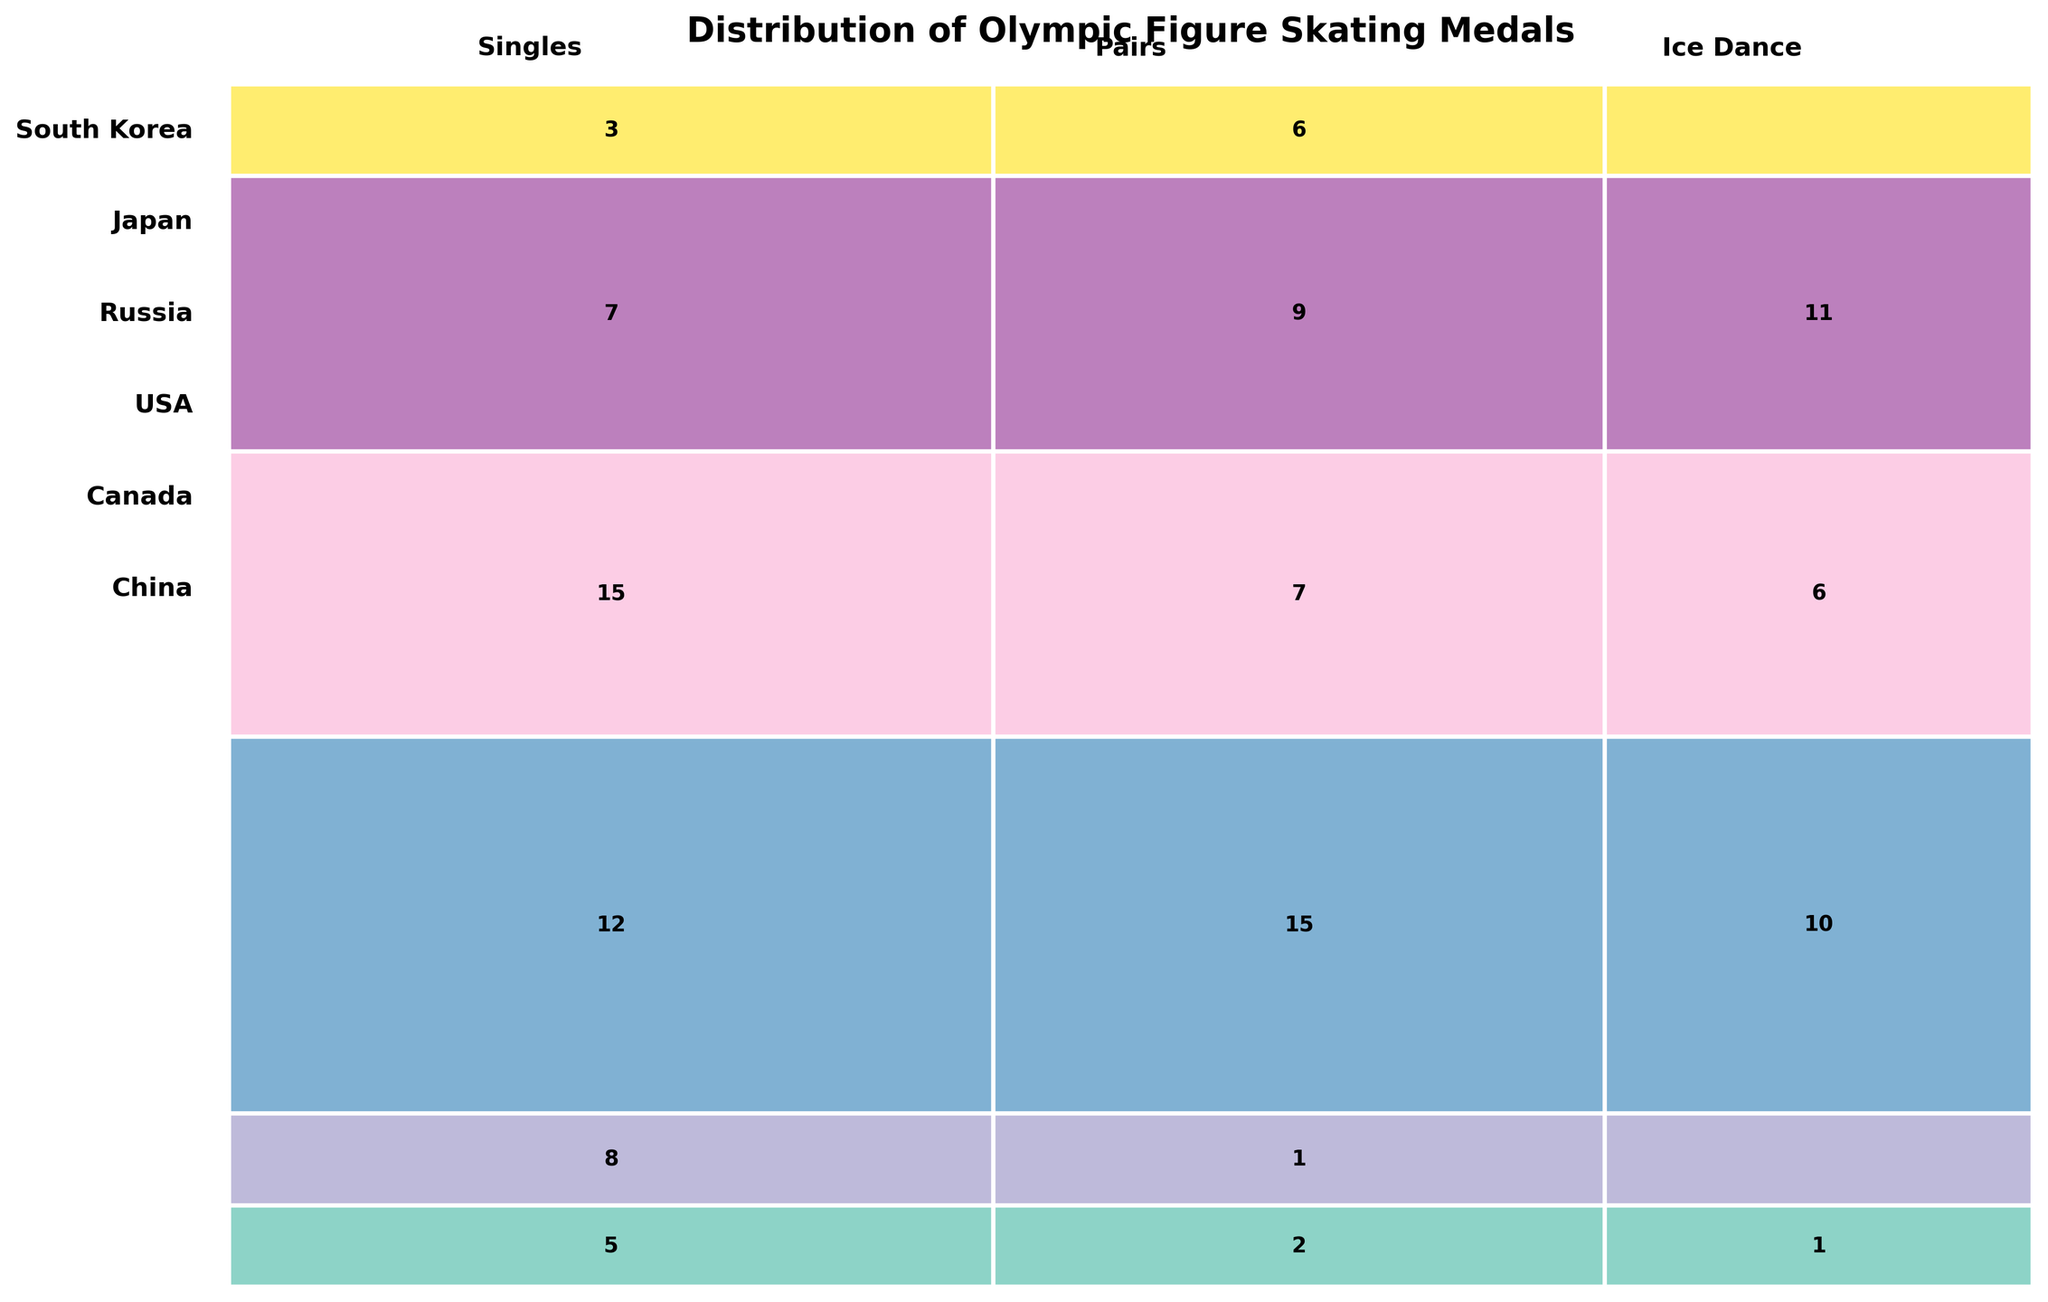Which country has the most medals in Singles figure skating? Look for the country with the largest rectangle in the Singles category and identify its corresponding medal count.
Answer: USA How many more medals does Russia have in Pairs compared to Ice Dance? Find the medal counts for Russia in both Pairs and Ice Dance, then subtract the Ice Dance count from the Pairs count (15 - 10).
Answer: 5 Which discipline has the least medals won by Japan? Identify the smallest rectangle in each discipline for Japan. The smallest is Ice Dance with a count of 0.
Answer: Ice Dance Compare the total medals won by South Korea and Canada. Which country has more? Add the medals from all disciplines for both South Korea and Canada. South Korea has 8 medals (5+2+1) and Canada has 27 (7+9+11).
Answer: Canada How do the number of medals won by China in Singles compare to those won in Pairs? Look at the numbers of the respective rectangles for China in Singles and Pairs. China has 3 in Singles and 6 in Pairs.
Answer: Pairs (6) are greater than Singles (3) Which discipline has the largest share of total medals? Compare the widths of the rectangles for each discipline to find the widest one.
Answer: Pairs How many total medals has the USA won across all disciplines? Add up the medal counts for the USA in Singles, Pairs, and Ice Dance (15+7+6).
Answer: 28 For South Korea and Japan, which country has more medals in Pairs and by how many? Compare the medal counts of South Korea and Japan in Pairs (2 for South Korea and 1 for Japan).
Answer: South Korea, by 1 In Ice Dance, which country has won the most medals? Identify the country with the largest rectangle in the Ice Dance column.
Answer: Canada Among the countries shown, which one has the smallest total medal count and what is it? Add up the total medals for each country and identify the smallest sum (South Korea with 8).
Answer: South Korea with 8 medals 